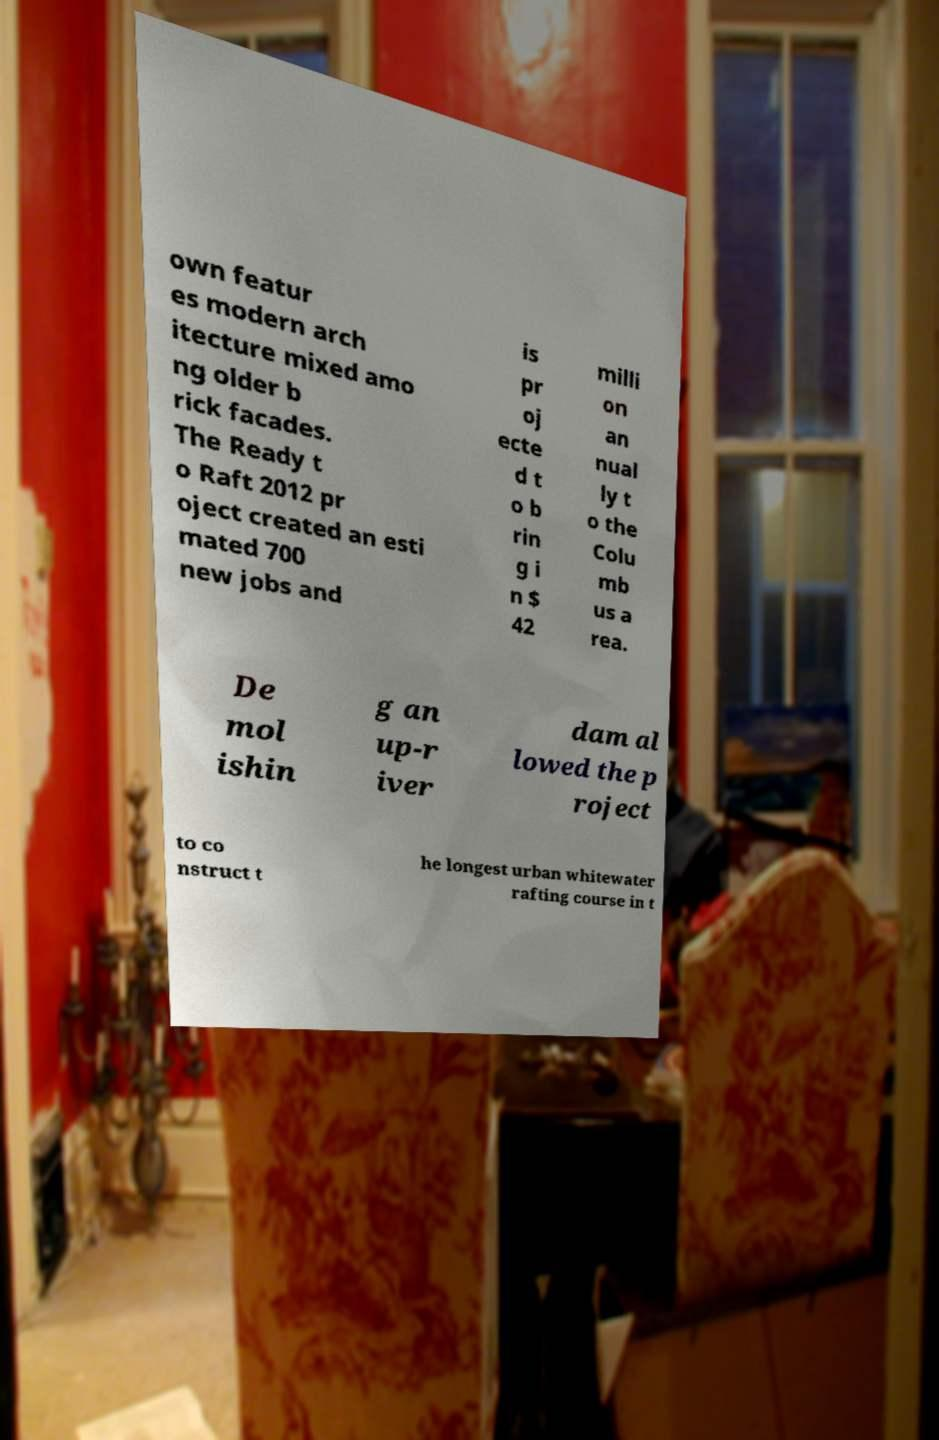What messages or text are displayed in this image? I need them in a readable, typed format. own featur es modern arch itecture mixed amo ng older b rick facades. The Ready t o Raft 2012 pr oject created an esti mated 700 new jobs and is pr oj ecte d t o b rin g i n $ 42 milli on an nual ly t o the Colu mb us a rea. De mol ishin g an up-r iver dam al lowed the p roject to co nstruct t he longest urban whitewater rafting course in t 